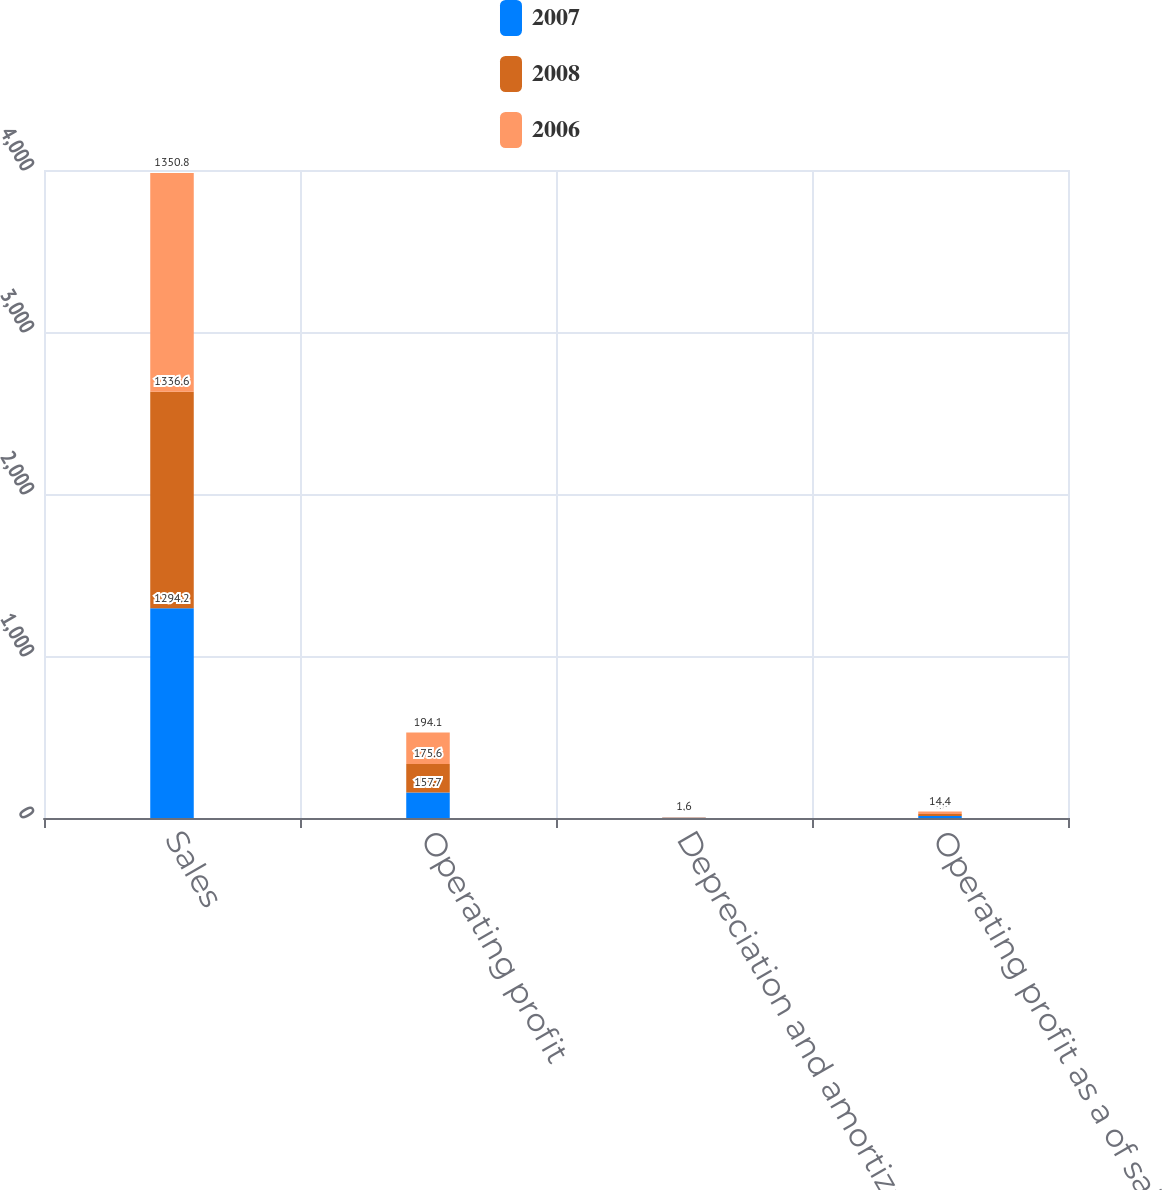Convert chart. <chart><loc_0><loc_0><loc_500><loc_500><stacked_bar_chart><ecel><fcel>Sales<fcel>Operating profit<fcel>Depreciation and amortization<fcel>Operating profit as a of sales<nl><fcel>2007<fcel>1294.2<fcel>157.7<fcel>1.6<fcel>12.2<nl><fcel>2008<fcel>1336.6<fcel>175.6<fcel>1.6<fcel>13.1<nl><fcel>2006<fcel>1350.8<fcel>194.1<fcel>1.6<fcel>14.4<nl></chart> 